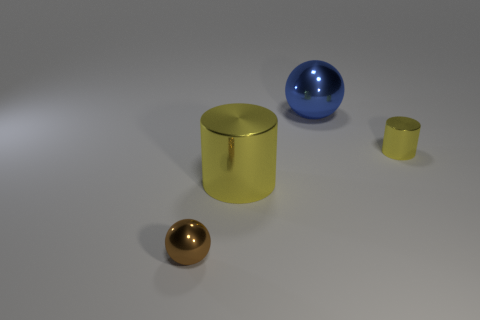There is a tiny cylinder that is the same color as the big shiny cylinder; what material is it?
Keep it short and to the point. Metal. Do the big metal cylinder and the tiny cylinder have the same color?
Give a very brief answer. Yes. Is there anything else that has the same material as the small ball?
Give a very brief answer. Yes. What shape is the brown object?
Make the answer very short. Sphere. The metallic thing that is the same size as the brown ball is what shape?
Ensure brevity in your answer.  Cylinder. Are there any other things that have the same color as the big cylinder?
Your response must be concise. Yes. The brown sphere that is the same material as the blue ball is what size?
Keep it short and to the point. Small. There is a large yellow metal object; is it the same shape as the tiny object to the right of the brown ball?
Offer a very short reply. Yes. What size is the brown metal object?
Ensure brevity in your answer.  Small. Is the number of big shiny things on the left side of the small brown object less than the number of tiny brown matte blocks?
Offer a terse response. No. 